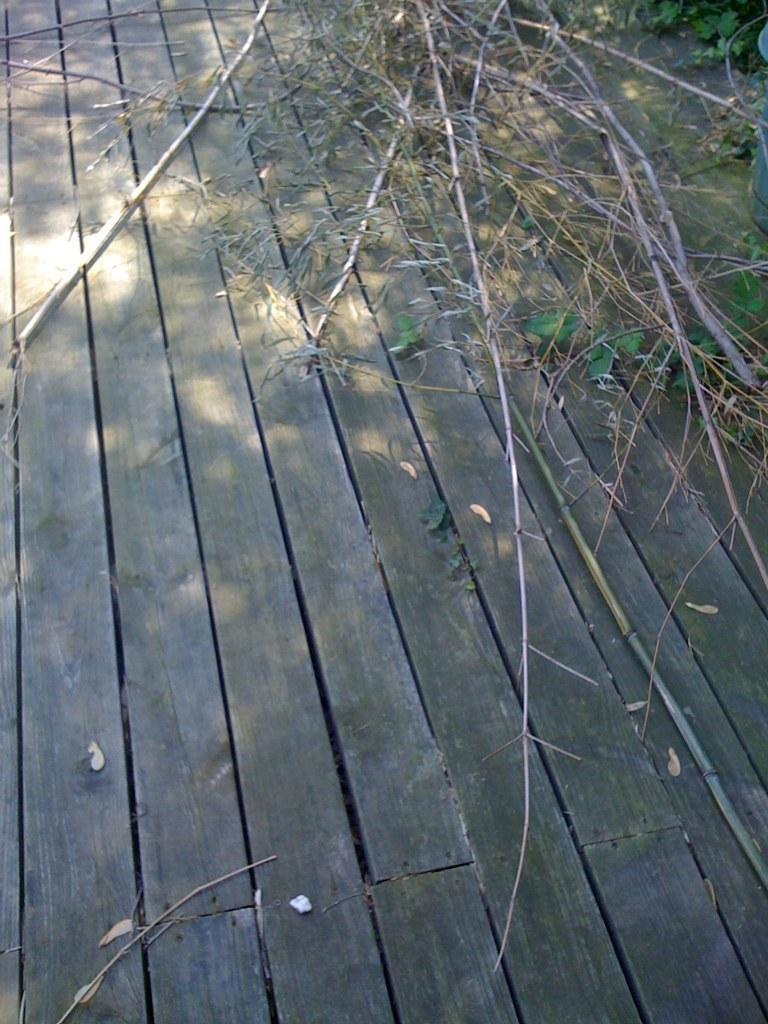What type of material is visible in the foreground of the image? There are wooden planks in the foreground of the image. What type of vegetation can be seen in the background of the image? There are green leaves and dry stems in the background of the image. How many goldfish are swimming in the wooden planks in the image? There are no goldfish present in the image; it features wooden planks and vegetation in the background. What type of snake can be seen slithering among the dry stems in the image? There is no snake present in the image; it features wooden planks and vegetation in the foreground and background. 